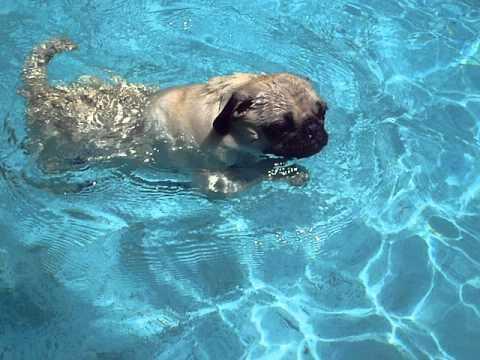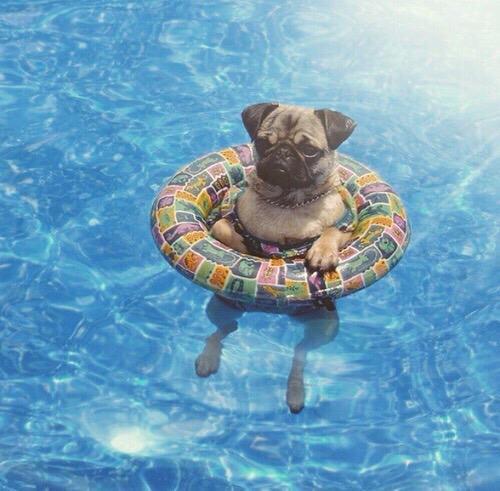The first image is the image on the left, the second image is the image on the right. Assess this claim about the two images: "there is a pug floating in a pool in an inter tube, the tube has a collage of images all over it". Correct or not? Answer yes or no. Yes. The first image is the image on the left, the second image is the image on the right. Given the left and right images, does the statement "In at least one image there is a pug in an intertube with his legs hanging down." hold true? Answer yes or no. Yes. 